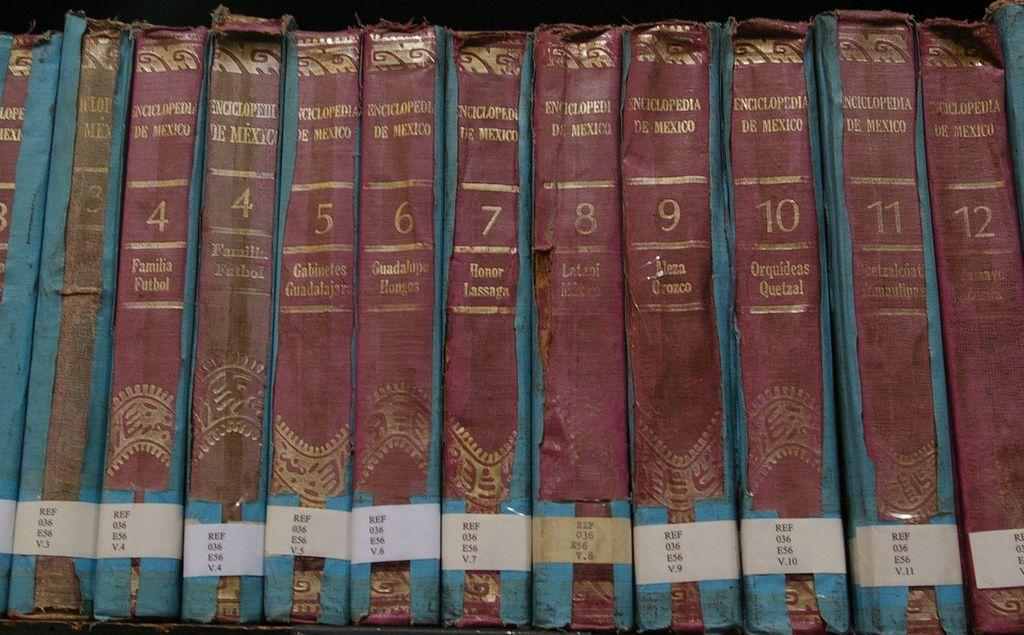Provide a one-sentence caption for the provided image. A set of very run down and decayed encyclopedias numbered beteen four and twelve. 